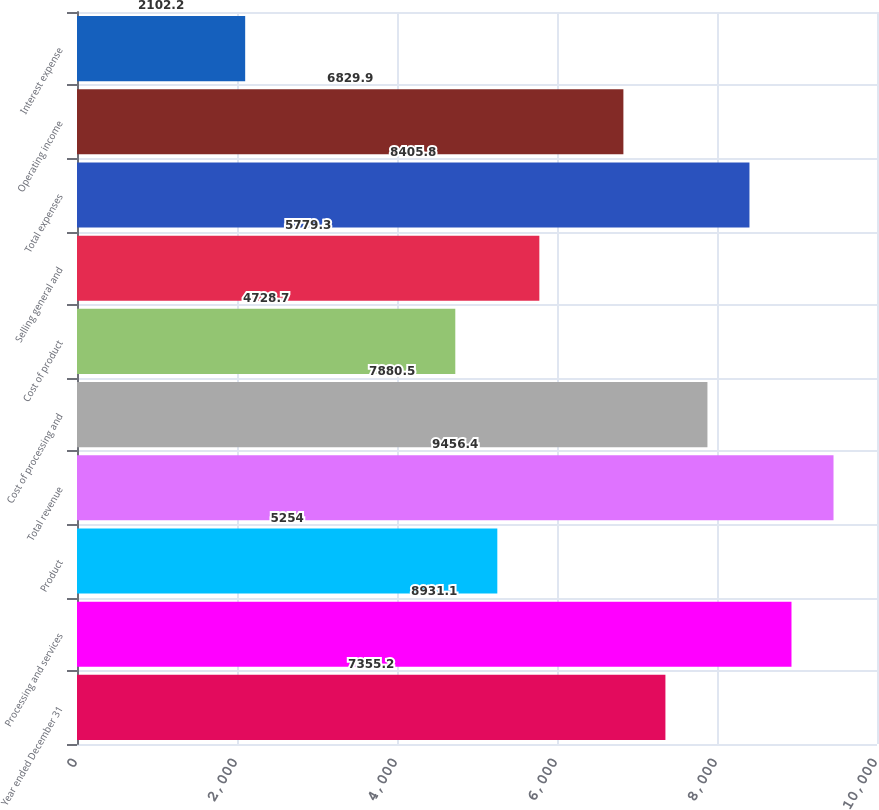Convert chart to OTSL. <chart><loc_0><loc_0><loc_500><loc_500><bar_chart><fcel>Year ended December 31<fcel>Processing and services<fcel>Product<fcel>Total revenue<fcel>Cost of processing and<fcel>Cost of product<fcel>Selling general and<fcel>Total expenses<fcel>Operating income<fcel>Interest expense<nl><fcel>7355.2<fcel>8931.1<fcel>5254<fcel>9456.4<fcel>7880.5<fcel>4728.7<fcel>5779.3<fcel>8405.8<fcel>6829.9<fcel>2102.2<nl></chart> 